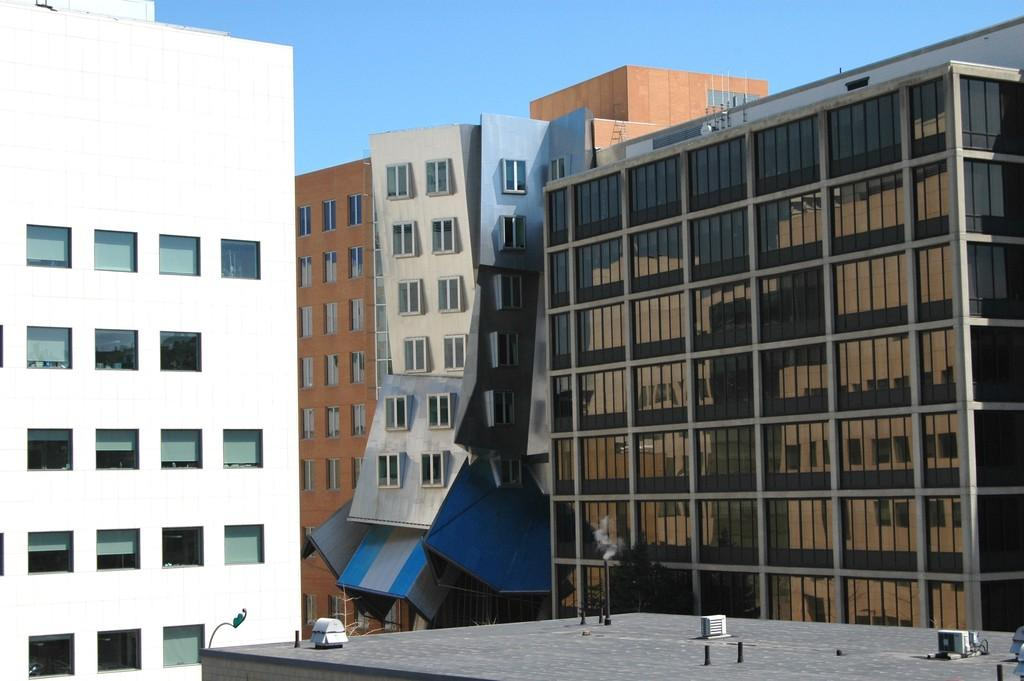What type of structures are present in the image? There are many buildings in the image. What colors are the buildings in the image? The buildings are in white, brown, and grey colors. What can be seen in the background of the image? The blue sky is visible in the background of the image. Where is the rabbit sitting in the image? There is no rabbit present in the image. What type of jam is being served with the buildings in the image? There is no jam present in the image; it features buildings and a blue sky. 